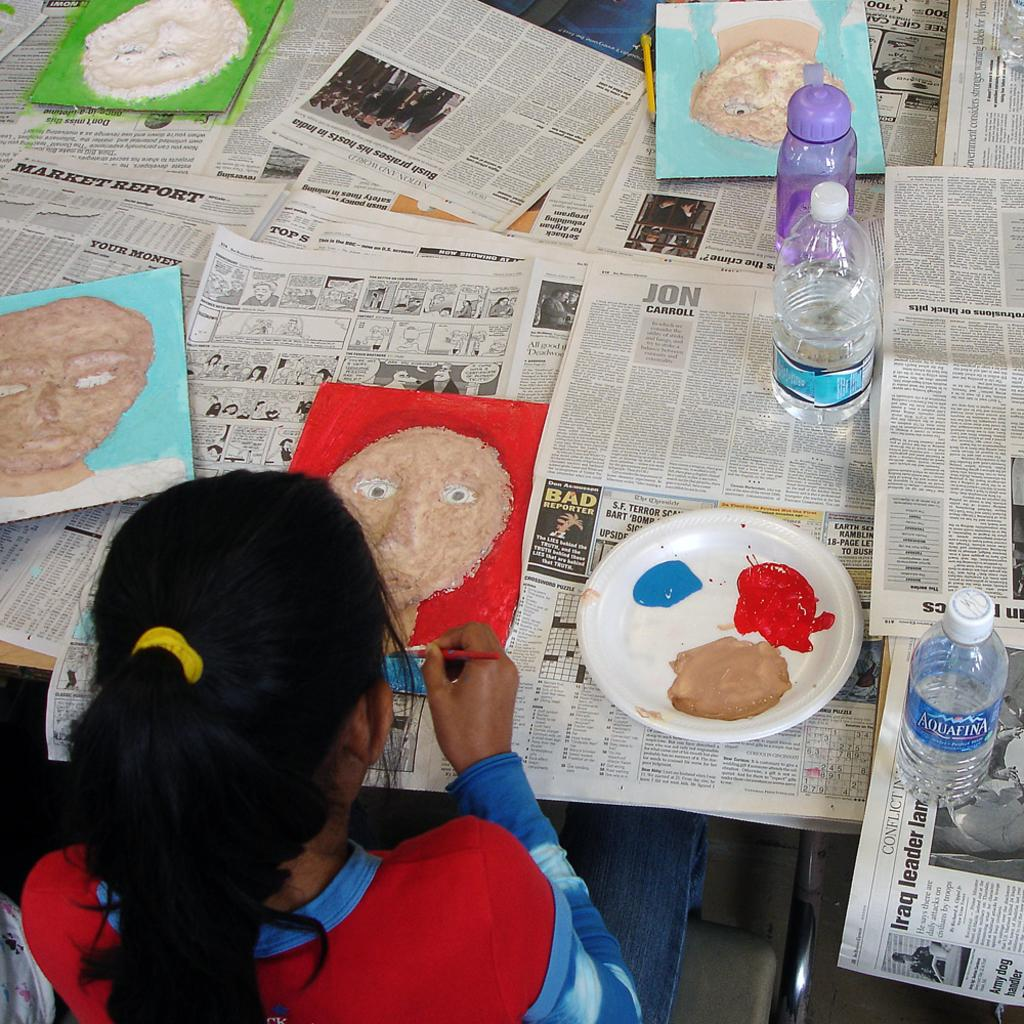What is the girl in the image doing? The girl is sitting and painting in the image. What items can be seen near the girl? There are water bottles and a plate of colors in the image. What is on the table in the image? There are paintings on the table in the image. What type of quill is the girl using to paint in the image? There is no quill present in the image; the girl is using a paintbrush or other painting tools. Can you tell me how many members are in the team that the girl is a part of in the image? There is no team or indication of a team in the image; it only shows the girl painting. 